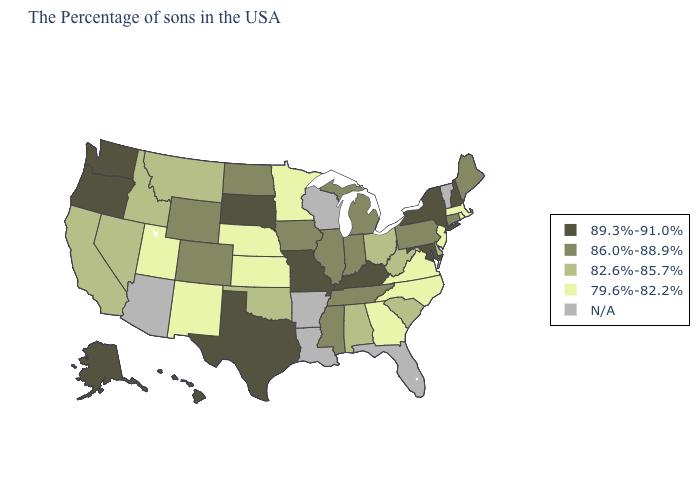What is the value of Iowa?
Write a very short answer. 86.0%-88.9%. What is the value of New Jersey?
Write a very short answer. 79.6%-82.2%. Name the states that have a value in the range 86.0%-88.9%?
Concise answer only. Maine, Connecticut, Pennsylvania, Michigan, Indiana, Tennessee, Illinois, Mississippi, Iowa, North Dakota, Wyoming, Colorado. Which states have the lowest value in the USA?
Answer briefly. Massachusetts, Rhode Island, New Jersey, Virginia, North Carolina, Georgia, Minnesota, Kansas, Nebraska, New Mexico, Utah. What is the value of Tennessee?
Write a very short answer. 86.0%-88.9%. Does the first symbol in the legend represent the smallest category?
Be succinct. No. Name the states that have a value in the range 79.6%-82.2%?
Concise answer only. Massachusetts, Rhode Island, New Jersey, Virginia, North Carolina, Georgia, Minnesota, Kansas, Nebraska, New Mexico, Utah. Name the states that have a value in the range 82.6%-85.7%?
Quick response, please. Delaware, South Carolina, West Virginia, Ohio, Alabama, Oklahoma, Montana, Idaho, Nevada, California. What is the value of Arkansas?
Give a very brief answer. N/A. Among the states that border Missouri , does Kentucky have the highest value?
Concise answer only. Yes. Among the states that border Oregon , which have the lowest value?
Quick response, please. Idaho, Nevada, California. Does the map have missing data?
Give a very brief answer. Yes. 